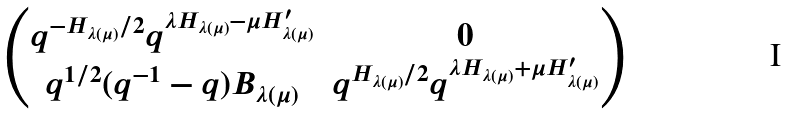<formula> <loc_0><loc_0><loc_500><loc_500>\begin{pmatrix} q ^ { - H _ { \lambda ( \mu ) } / 2 } q ^ { \lambda H _ { \lambda ( \mu ) } - \mu H ^ { \prime } _ { \lambda ( \mu ) } } & 0 \\ q ^ { 1 / 2 } ( q ^ { - 1 } - q ) B _ { \lambda ( \mu ) } & q ^ { H _ { \lambda ( \mu ) } / 2 } q ^ { \lambda H _ { \lambda ( \mu ) } + \mu H ^ { \prime } _ { \lambda ( \mu ) } } \end{pmatrix}</formula> 